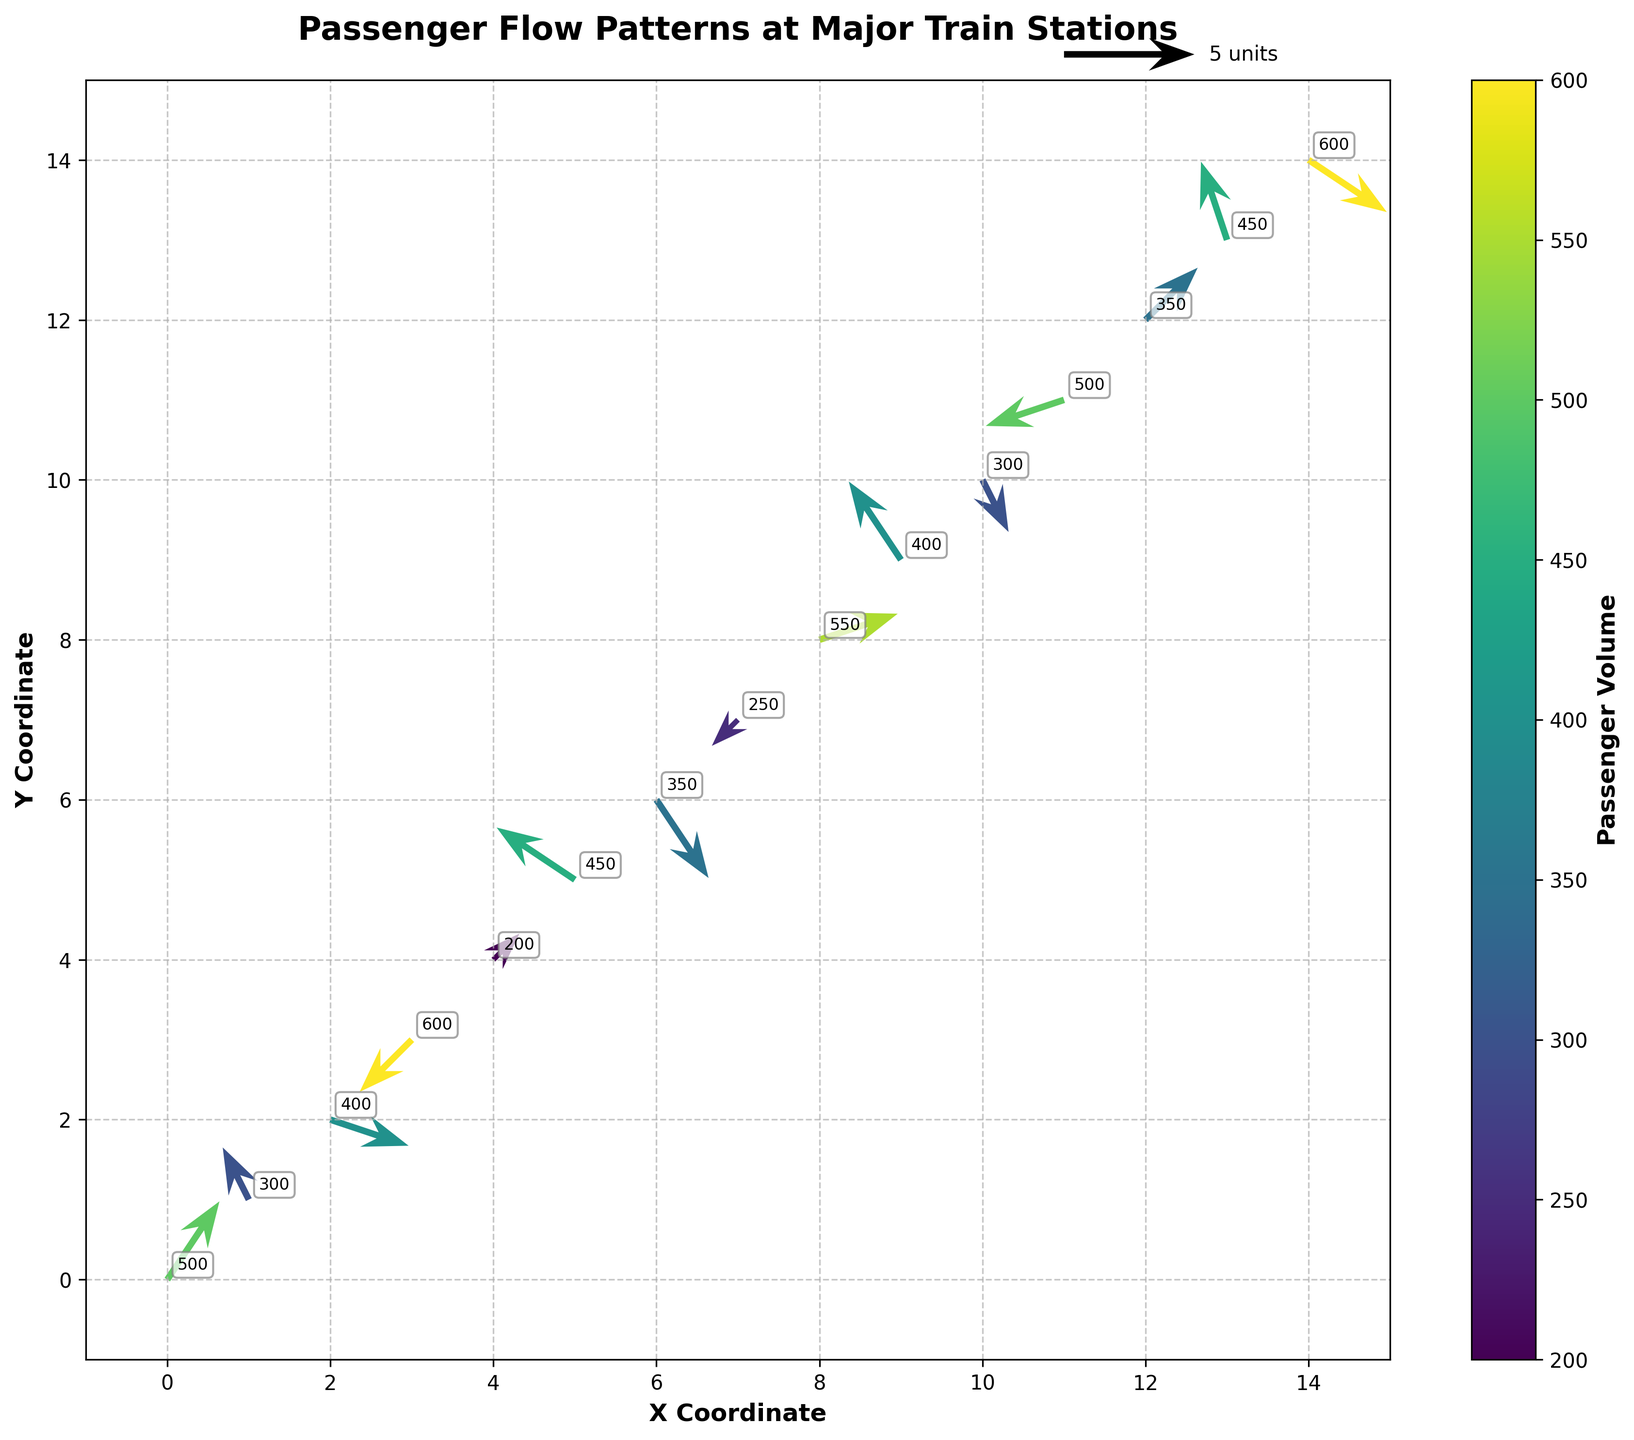what is the title of the plot? The title of the plot is displayed at the top of the figure in a prominent font. It gives an overview of what the plot represents. The title reads "Passenger Flow Patterns at Major Train Stations".
Answer: Passenger Flow Patterns at Major Train Stations what do the x and y axes represent? The labels on the x and y axes, "X Coordinate" and "Y Coordinate" respectively, indicate the spatial coordinates of the passenger flow data at the train stations.
Answer: X and Y Coordinates how many major train stations are represented in this plot? The number of quiver arrows corresponds to the number of major train stations represented. By counting the arrows, we see there are 15 major train stations.
Answer: 15 which station has the highest passenger volume? The color bar indicates passenger volume with magnitude annotated next to each arrow. The station at coordinates (14,14) has a volume of 600, which is the highest value.
Answer: Station at (14,14) what is the magnitude of passenger volume at the station located at (8, 8)? The annotation next to the arrow at coordinates (8,8) shows the magnitude of the passenger volume, which is 550.
Answer: 550 how does the direction of movement at (2,2) compare to that at (11,11)? At (2,2), the arrow points mostly to the right and slightly downward, indicating movement to the southeast. At (11,11), the arrow points to the left and slightly downward, indicating movement to the southwest.
Answer: Southeast at (2,2), Southwest at (11,11) what is the average magnitude of passenger volume for the stations at (7,7) and (10,10)? Magnitude at (7,7) is 250 and at (10,10) is 300. The average magnitude is calculated as (250 + 300) / 2 = 275.
Answer: 275 which direction represents the majority of movements at the stations? The majority directions can be inferred by visually inspecting the arrows and the quadrant they point towards. Most arrows point towards the northwest to southeast direction, indicating a dominant flow in these directions.
Answer: Northwest to Southeast are there more stations with positive or negative x-direction flow? To determine this, count the arrows with positive and negative 'u' components. There are more arrows with positive 'u' (including (0,0), (2,2), (4,4), (6,6), (8,8), (10,10), (12,12), (14,14)) than negative 'u' components (including (1,1), (3,3), (5,5), (7,7), (9,9), (11,11), (13,13)).
Answer: Positive x-direction flow 